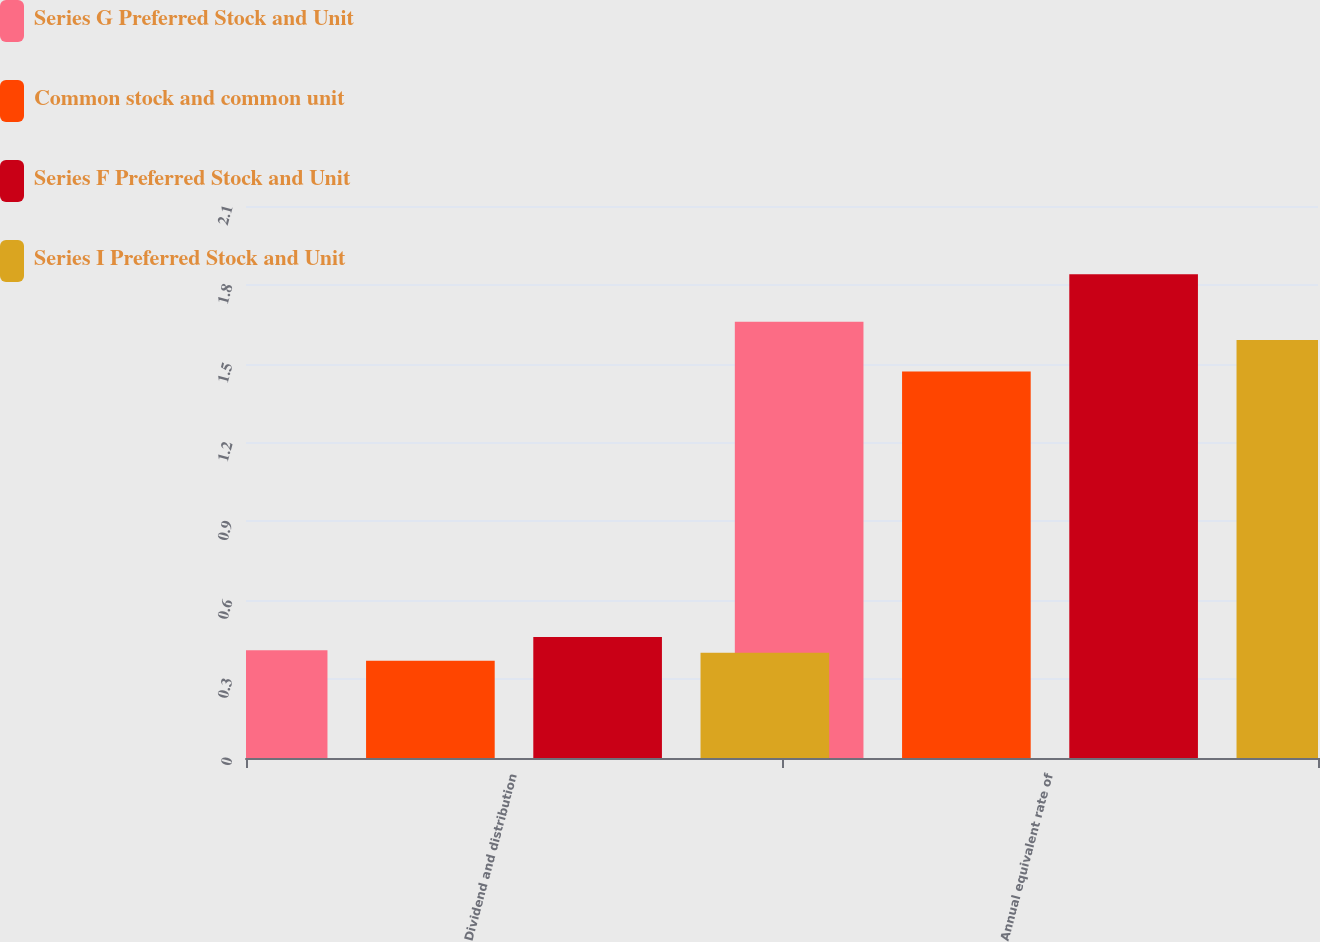<chart> <loc_0><loc_0><loc_500><loc_500><stacked_bar_chart><ecel><fcel>Dividend and distribution<fcel>Annual equivalent rate of<nl><fcel>Series G Preferred Stock and Unit<fcel>0.41<fcel>1.66<nl><fcel>Common stock and common unit<fcel>0.37<fcel>1.47<nl><fcel>Series F Preferred Stock and Unit<fcel>0.46<fcel>1.84<nl><fcel>Series I Preferred Stock and Unit<fcel>0.4<fcel>1.59<nl></chart> 